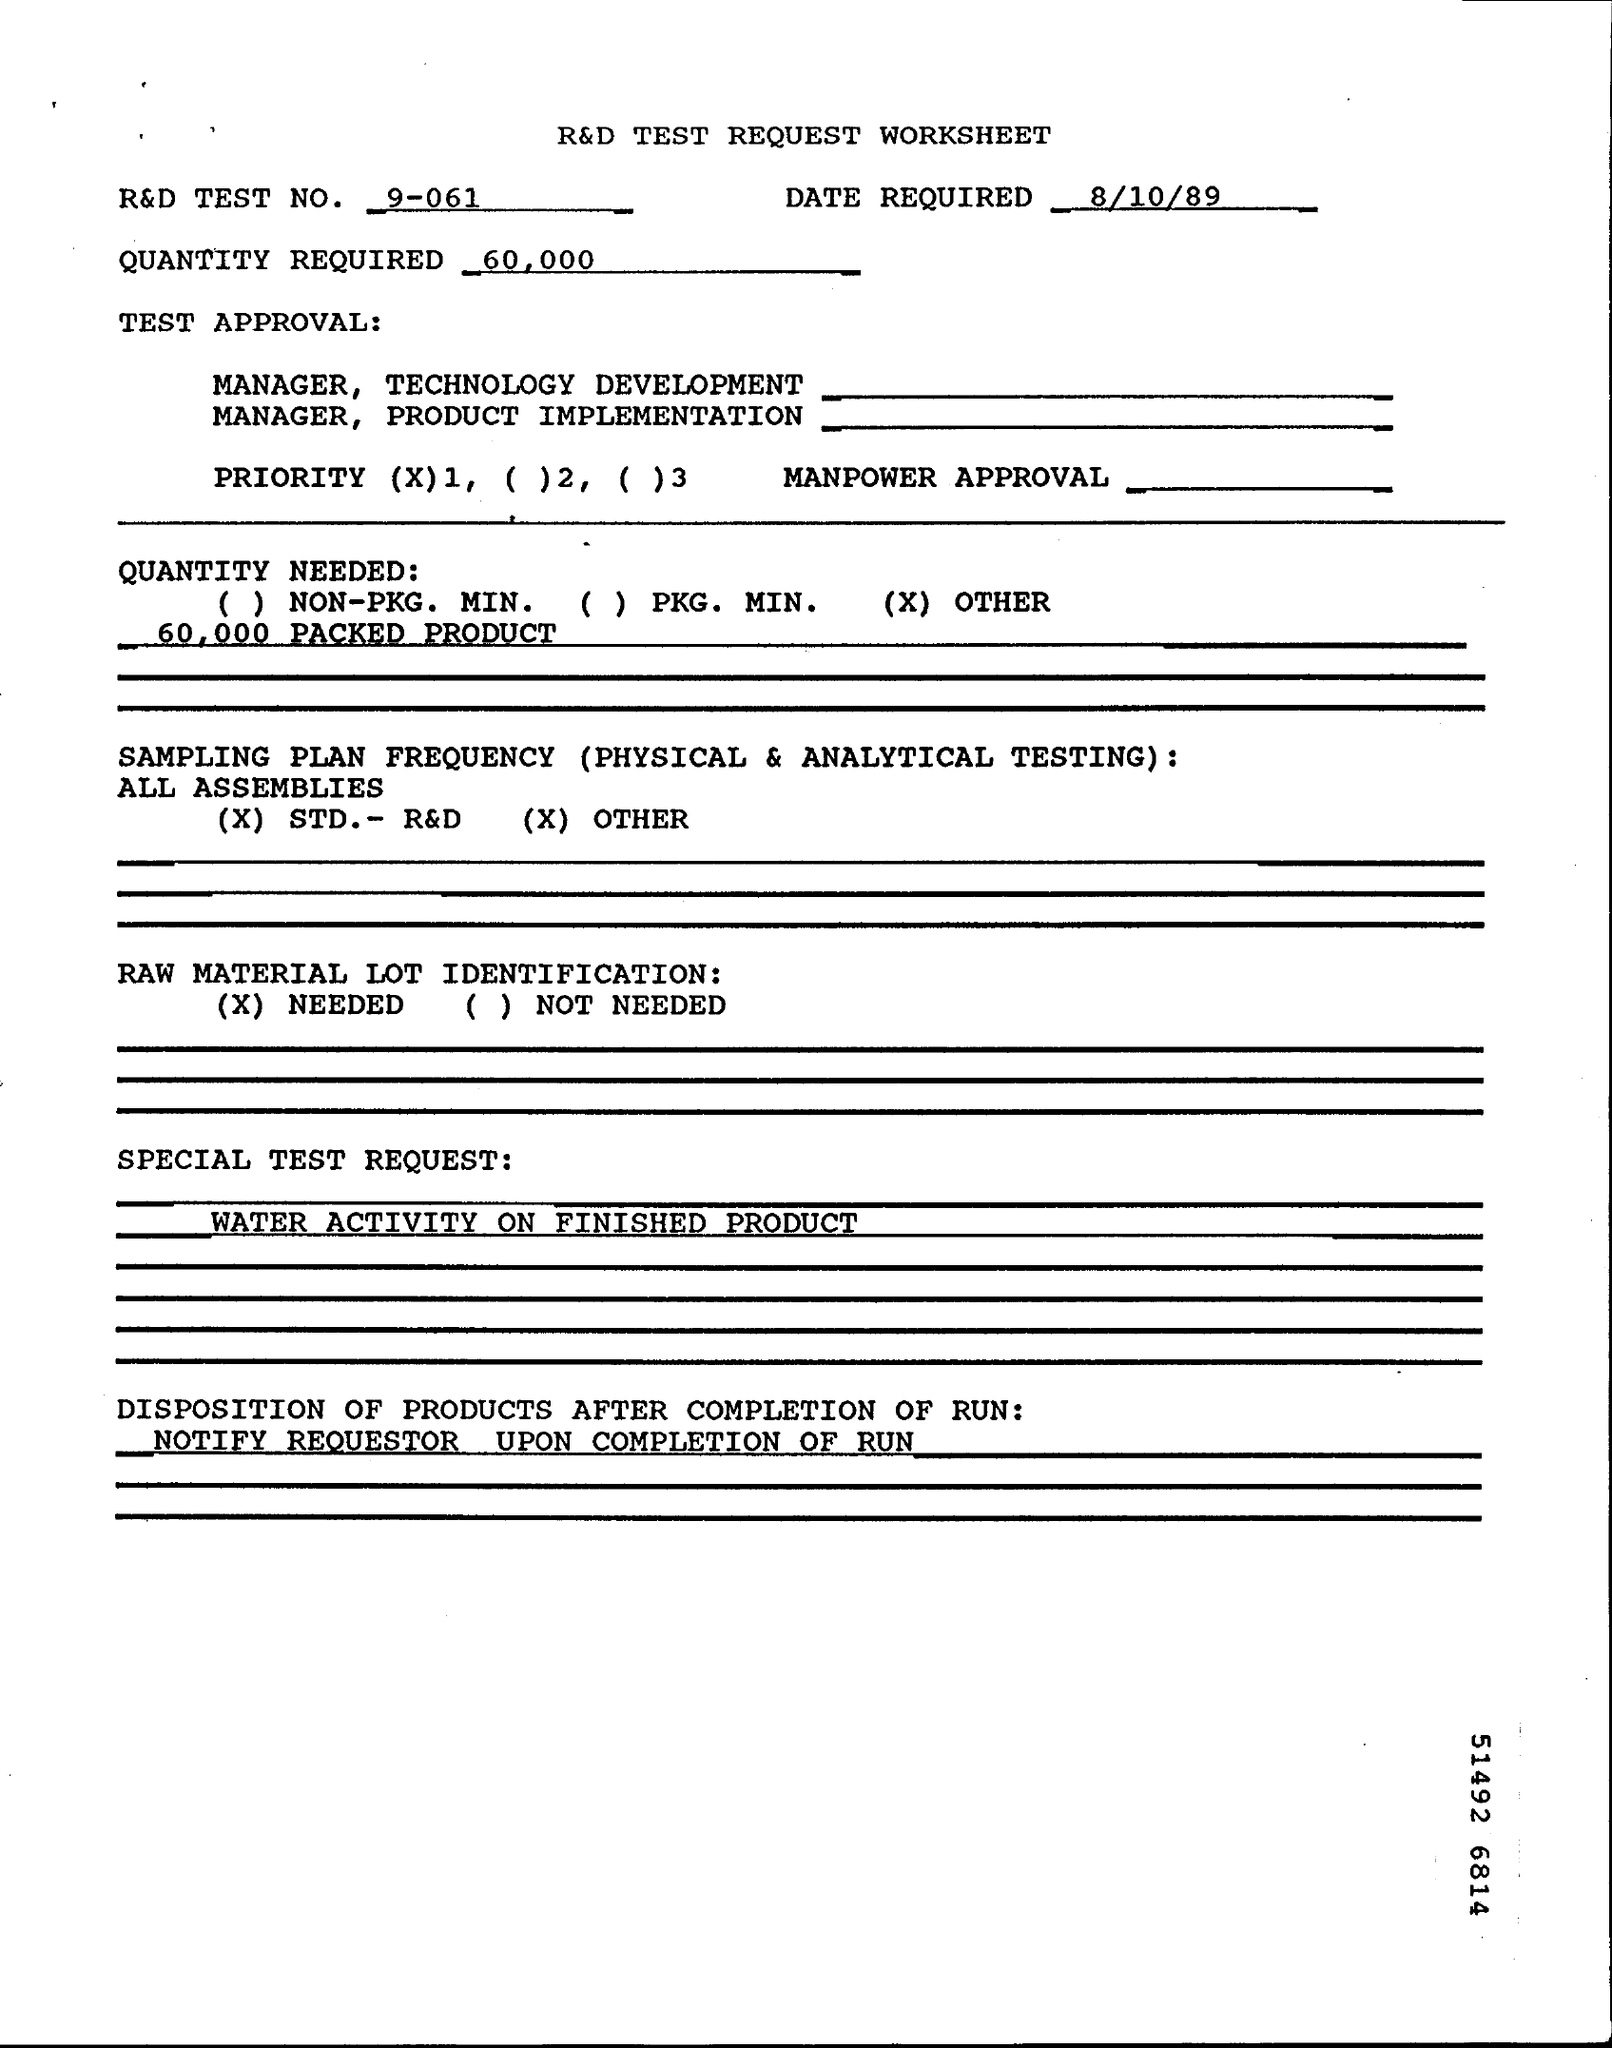Highlight a few significant elements in this photo. The R&D test number is 9-061. On what date is the date required? The special test request is to determine the water activity of the finished product. 